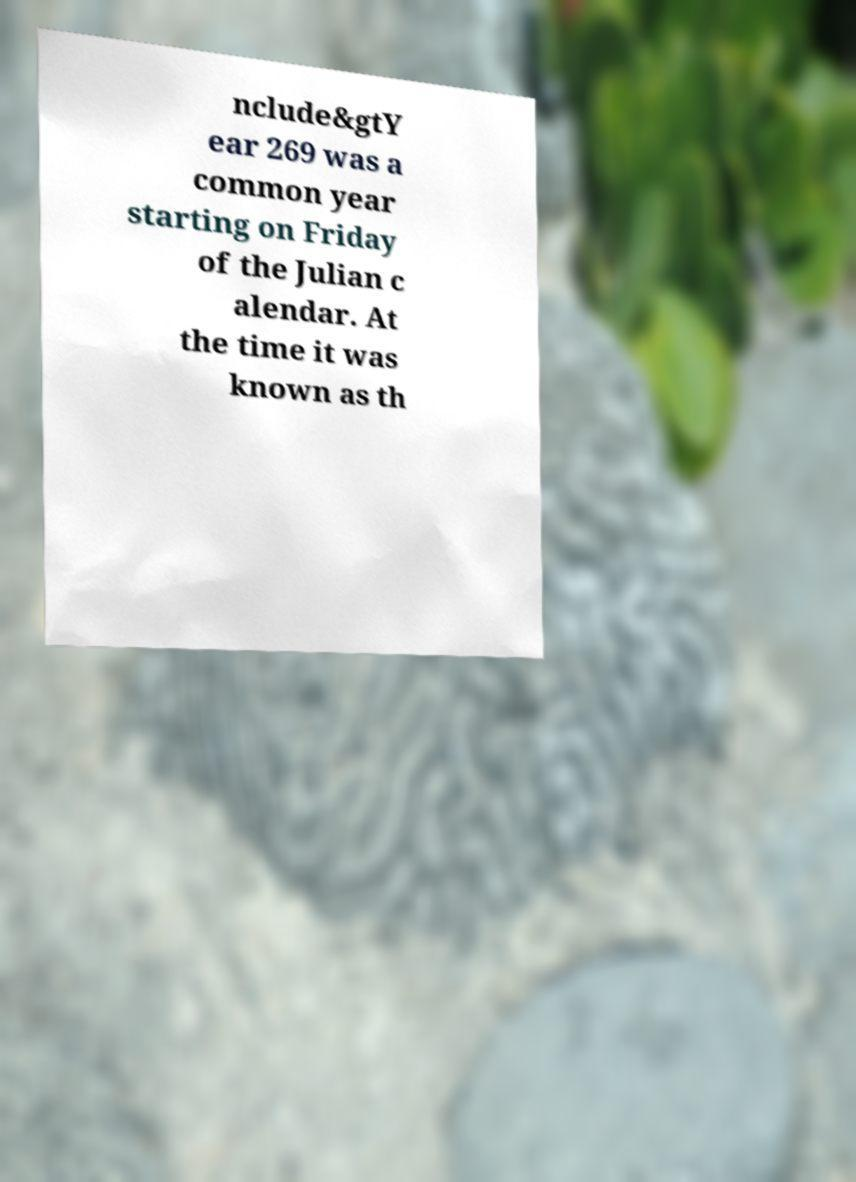Please identify and transcribe the text found in this image. nclude&gtY ear 269 was a common year starting on Friday of the Julian c alendar. At the time it was known as th 